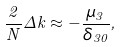<formula> <loc_0><loc_0><loc_500><loc_500>\frac { 2 } { N } \Delta k \approx - \frac { \mu _ { 3 } } { \delta _ { 3 0 } } ,</formula> 